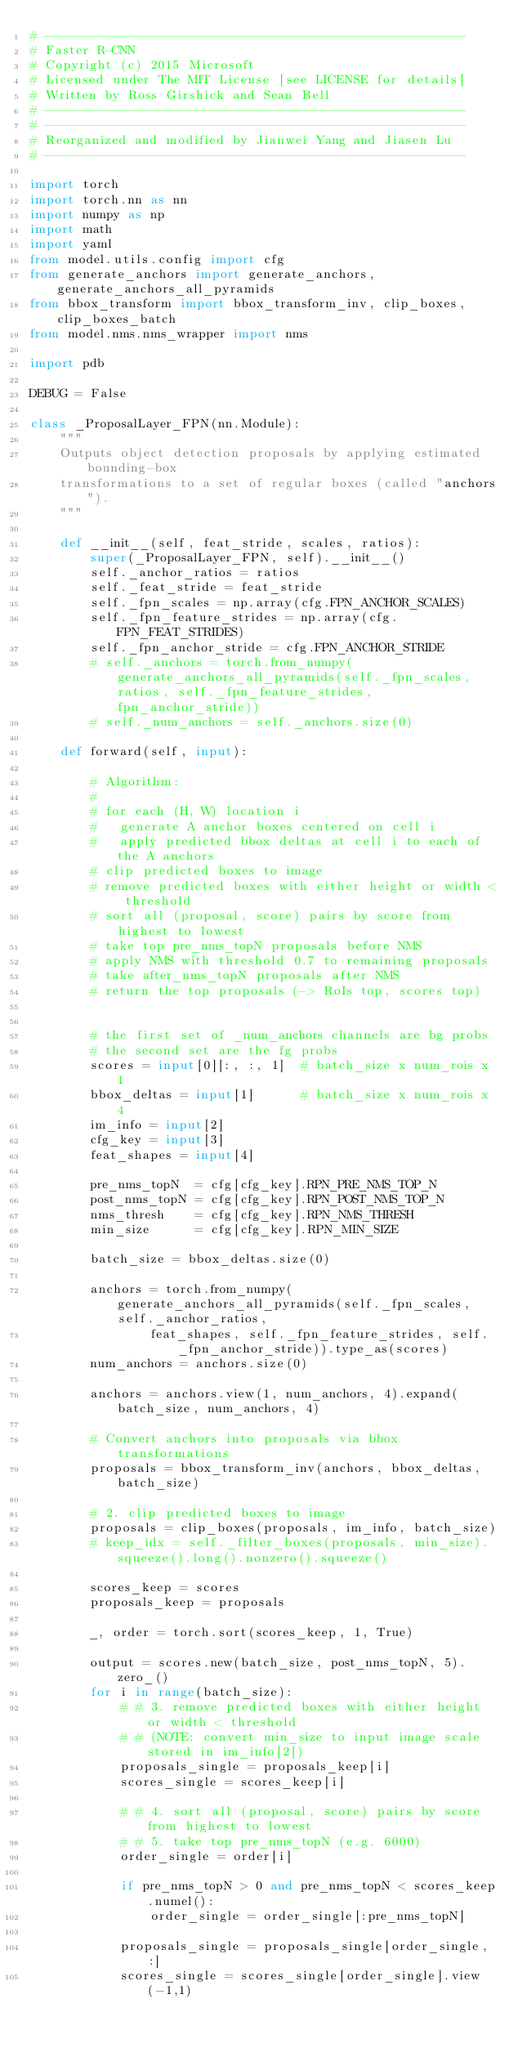Convert code to text. <code><loc_0><loc_0><loc_500><loc_500><_Python_># --------------------------------------------------------
# Faster R-CNN
# Copyright (c) 2015 Microsoft
# Licensed under The MIT License [see LICENSE for details]
# Written by Ross Girshick and Sean Bell
# --------------------------------------------------------
# --------------------------------------------------------
# Reorganized and modified by Jianwei Yang and Jiasen Lu
# --------------------------------------------------------

import torch
import torch.nn as nn
import numpy as np
import math
import yaml
from model.utils.config import cfg
from generate_anchors import generate_anchors, generate_anchors_all_pyramids
from bbox_transform import bbox_transform_inv, clip_boxes, clip_boxes_batch
from model.nms.nms_wrapper import nms

import pdb

DEBUG = False

class _ProposalLayer_FPN(nn.Module):
    """
    Outputs object detection proposals by applying estimated bounding-box
    transformations to a set of regular boxes (called "anchors").
    """

    def __init__(self, feat_stride, scales, ratios):
        super(_ProposalLayer_FPN, self).__init__()
        self._anchor_ratios = ratios
        self._feat_stride = feat_stride
        self._fpn_scales = np.array(cfg.FPN_ANCHOR_SCALES)
        self._fpn_feature_strides = np.array(cfg.FPN_FEAT_STRIDES)
        self._fpn_anchor_stride = cfg.FPN_ANCHOR_STRIDE
        # self._anchors = torch.from_numpy(generate_anchors_all_pyramids(self._fpn_scales, ratios, self._fpn_feature_strides, fpn_anchor_stride))
        # self._num_anchors = self._anchors.size(0)

    def forward(self, input):

        # Algorithm:
        #
        # for each (H, W) location i
        #   generate A anchor boxes centered on cell i
        #   apply predicted bbox deltas at cell i to each of the A anchors
        # clip predicted boxes to image
        # remove predicted boxes with either height or width < threshold
        # sort all (proposal, score) pairs by score from highest to lowest
        # take top pre_nms_topN proposals before NMS
        # apply NMS with threshold 0.7 to remaining proposals
        # take after_nms_topN proposals after NMS
        # return the top proposals (-> RoIs top, scores top)


        # the first set of _num_anchors channels are bg probs
        # the second set are the fg probs
        scores = input[0][:, :, 1]  # batch_size x num_rois x 1
        bbox_deltas = input[1]      # batch_size x num_rois x 4
        im_info = input[2]
        cfg_key = input[3]
        feat_shapes = input[4]        

        pre_nms_topN  = cfg[cfg_key].RPN_PRE_NMS_TOP_N
        post_nms_topN = cfg[cfg_key].RPN_POST_NMS_TOP_N
        nms_thresh    = cfg[cfg_key].RPN_NMS_THRESH
        min_size      = cfg[cfg_key].RPN_MIN_SIZE

        batch_size = bbox_deltas.size(0)

        anchors = torch.from_numpy(generate_anchors_all_pyramids(self._fpn_scales, self._anchor_ratios, 
                feat_shapes, self._fpn_feature_strides, self._fpn_anchor_stride)).type_as(scores)
        num_anchors = anchors.size(0)

        anchors = anchors.view(1, num_anchors, 4).expand(batch_size, num_anchors, 4)

        # Convert anchors into proposals via bbox transformations
        proposals = bbox_transform_inv(anchors, bbox_deltas, batch_size)

        # 2. clip predicted boxes to image
        proposals = clip_boxes(proposals, im_info, batch_size)
        # keep_idx = self._filter_boxes(proposals, min_size).squeeze().long().nonzero().squeeze()
                
        scores_keep = scores
        proposals_keep = proposals

        _, order = torch.sort(scores_keep, 1, True)

        output = scores.new(batch_size, post_nms_topN, 5).zero_()
        for i in range(batch_size):
            # # 3. remove predicted boxes with either height or width < threshold
            # # (NOTE: convert min_size to input image scale stored in im_info[2])
            proposals_single = proposals_keep[i]
            scores_single = scores_keep[i]

            # # 4. sort all (proposal, score) pairs by score from highest to lowest
            # # 5. take top pre_nms_topN (e.g. 6000)
            order_single = order[i]

            if pre_nms_topN > 0 and pre_nms_topN < scores_keep.numel():
                order_single = order_single[:pre_nms_topN]

            proposals_single = proposals_single[order_single, :]
            scores_single = scores_single[order_single].view(-1,1)
</code> 